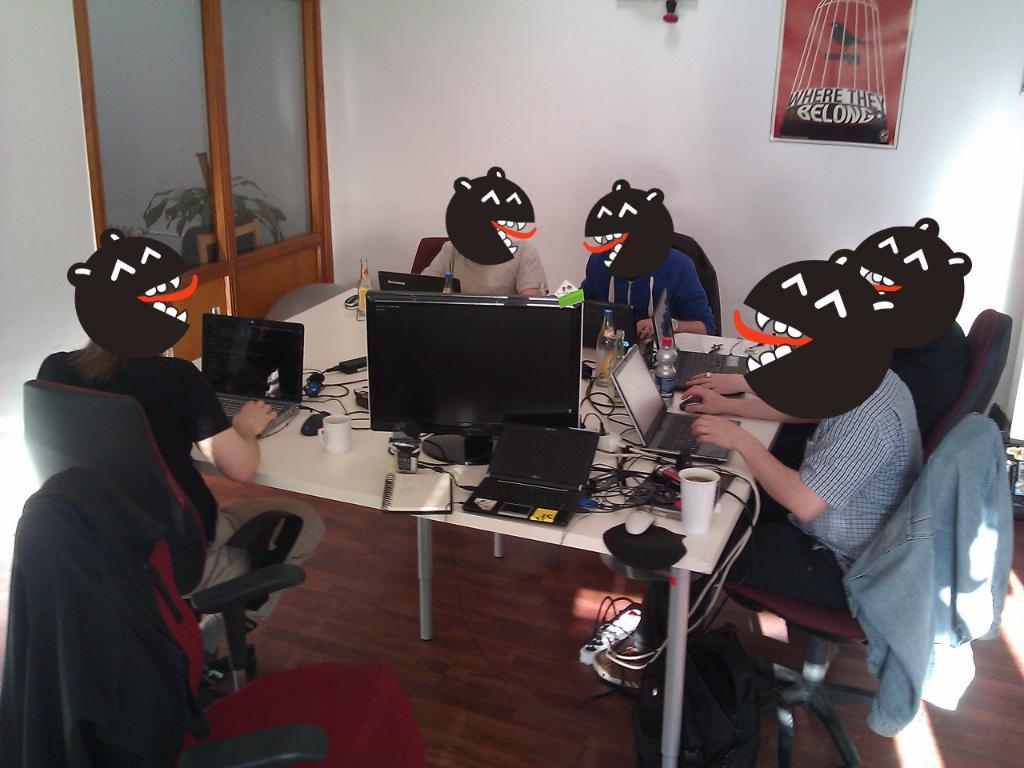How many people are in the image? There is a group of people in the image. What are the people doing in the image? The people are sitting on chairs. Where are the chairs located in relation to the table? The chairs are in front of a table. What electronic device is on the table? There is a laptop on the table. What other objects can be seen on the table? There are other objects on the table. What is the size of the snail crawling on the laptop in the image? There is no snail present in the image, so we cannot determine its size. 